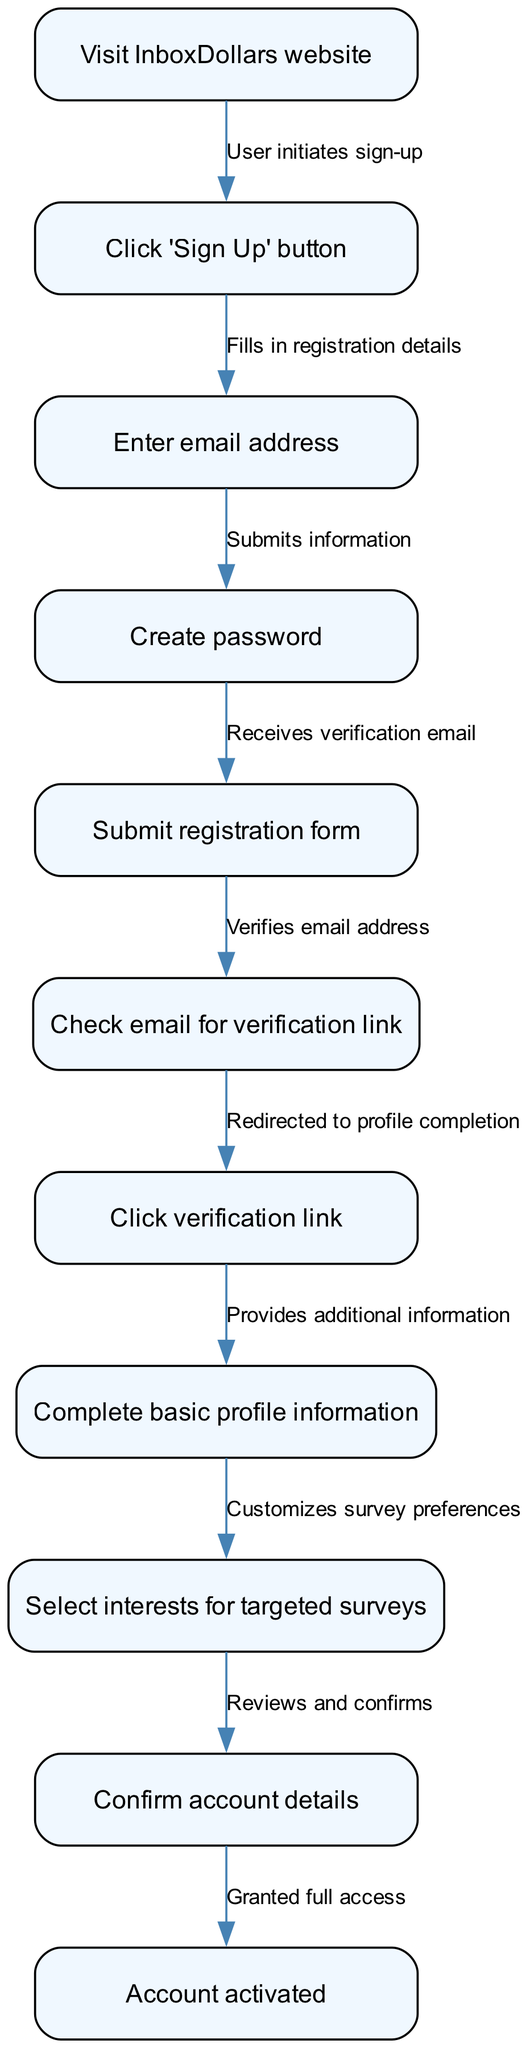What is the first step in the sign-up process? The first step in the sign-up process as represented in the diagram is "Visit InboxDollars website." This is the initial action that leads to the subsequent steps in the user sign-up process.
Answer: Visit InboxDollars website How many nodes are there in total? The diagram contains a total of 11 nodes representing different actions taken during the sign-up process. By counting each unique action listed, we determine the total.
Answer: 11 What comes after "Click 'Sign Up' button"? After "Click 'Sign Up' button," the next action is "Enter email address." This shows the direct flow from one step to the next in the process.
Answer: Enter email address What is the last step in the sign-up process? The last step in the sign-up process is "Account activated." This indicates the successful completion of the registration process.
Answer: Account activated How many edges are used in the diagram? The diagram uses a total of 9 edges which represent the relationships between the nodes, indicating the flow from one action to another in the user sign-up process.
Answer: 9 What action follows email verification? The action that follows email verification ("Click verification link") is "Complete basic profile information." This shows the progression after the user confirms their email.
Answer: Complete basic profile information Which step requires the user to select interests? The step where the user is required to select interests for targeted surveys is "Select interests for targeted surveys." This allows for personalized survey offers based on user preferences.
Answer: Select interests for targeted surveys What connects “Submit registration form” to the next step? The edge that connects "Submit registration form" to the next step is labeled "Submits information." This indicates that the action of submitting leads to receiving an email for verification.
Answer: Submits information Which node leads directly to account activation? The node that leads directly to account activation is "Confirm account details." This step comes right before the account is officially activated for use.
Answer: Confirm account details 